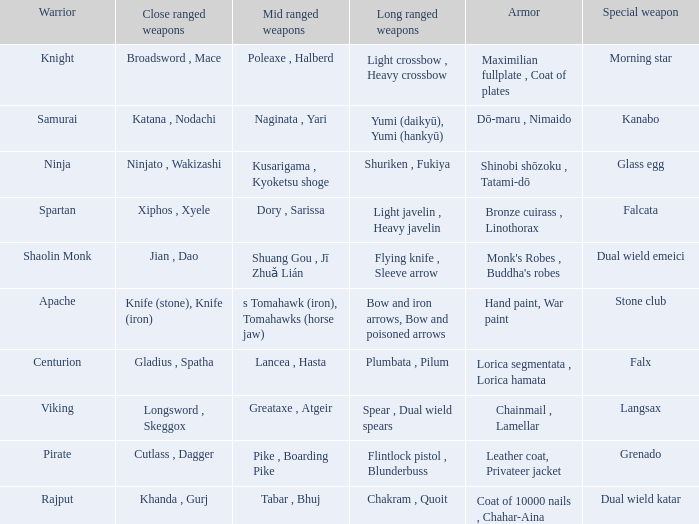If the Close ranged weapons are the knife (stone), knife (iron), what are the Long ranged weapons? Bow and iron arrows, Bow and poisoned arrows. 